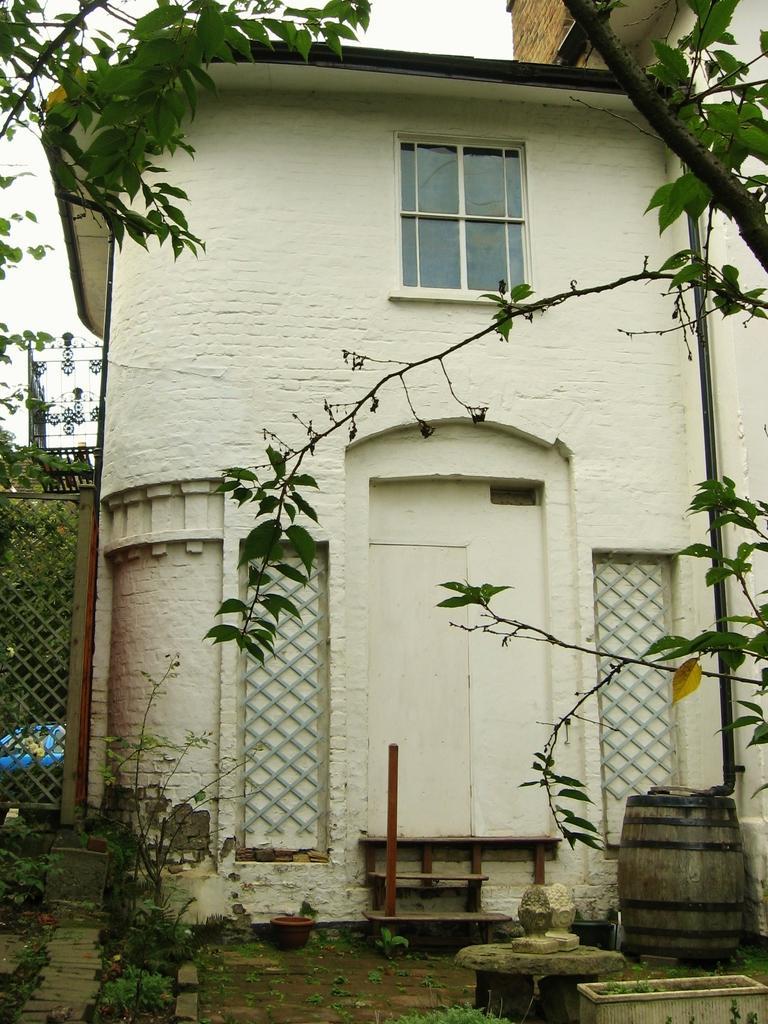Can you describe this image briefly? In this image I can see the building and there is a window to it. To the left I can see the railing and there are many trees in-front of the building. I can also see the barrel and the rocks in the front. In the back there are trees. 